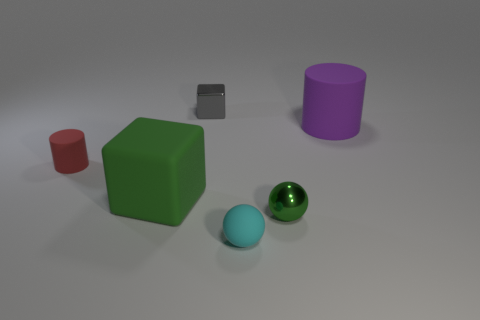There is a large thing that is the same color as the metal sphere; what is its material?
Offer a very short reply. Rubber. There is a tiny metallic sphere; is it the same color as the large thing that is on the left side of the cyan matte object?
Ensure brevity in your answer.  Yes. There is a object that is the same color as the matte cube; what size is it?
Ensure brevity in your answer.  Small. The metal object that is the same color as the big matte block is what shape?
Offer a terse response. Sphere. Are there fewer small rubber cylinders than red shiny cylinders?
Provide a short and direct response. No. The other small thing that is made of the same material as the red thing is what shape?
Give a very brief answer. Sphere. There is a small matte cylinder; are there any small rubber objects right of it?
Keep it short and to the point. Yes. Is the number of big green objects that are behind the large matte cylinder less than the number of big metallic cubes?
Provide a short and direct response. No. What material is the tiny gray object?
Make the answer very short. Metal. What is the color of the tiny metal block?
Offer a very short reply. Gray. 